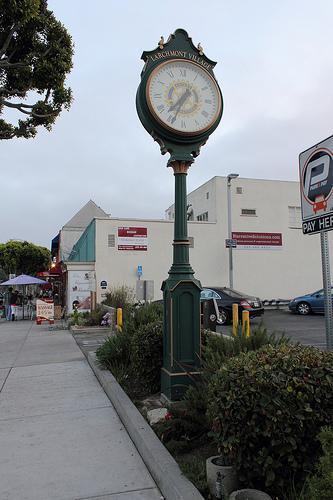How many clocks are in the picture?
Give a very brief answer. 1. 